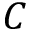<formula> <loc_0><loc_0><loc_500><loc_500>C</formula> 